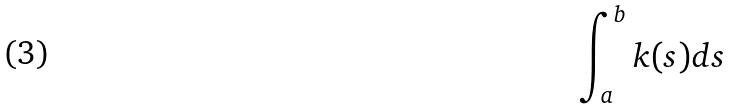<formula> <loc_0><loc_0><loc_500><loc_500>\int _ { a } ^ { b } k ( s ) d s</formula> 